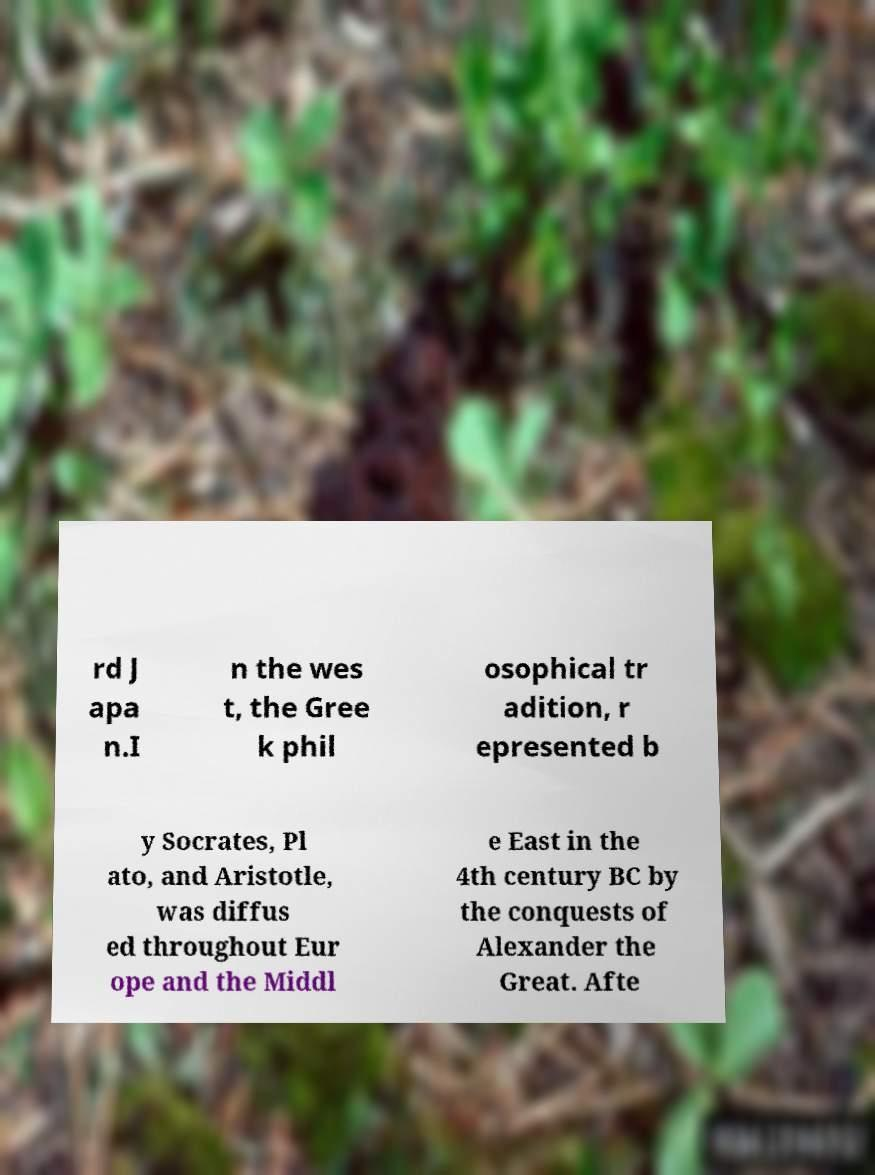Can you accurately transcribe the text from the provided image for me? rd J apa n.I n the wes t, the Gree k phil osophical tr adition, r epresented b y Socrates, Pl ato, and Aristotle, was diffus ed throughout Eur ope and the Middl e East in the 4th century BC by the conquests of Alexander the Great. Afte 